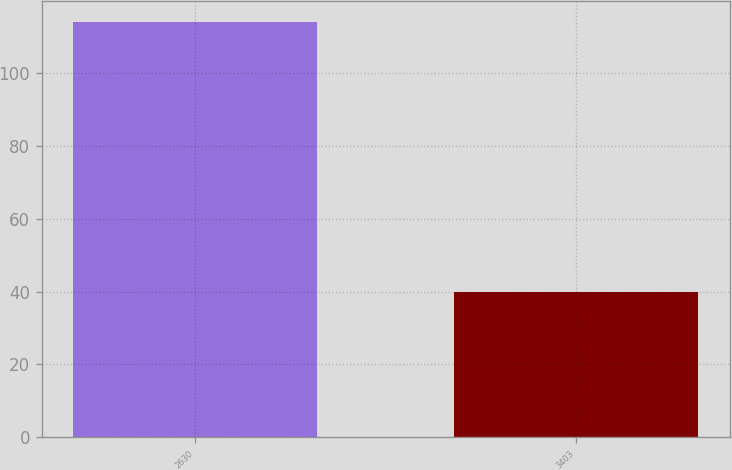<chart> <loc_0><loc_0><loc_500><loc_500><bar_chart><fcel>2630<fcel>3403<nl><fcel>114<fcel>40<nl></chart> 